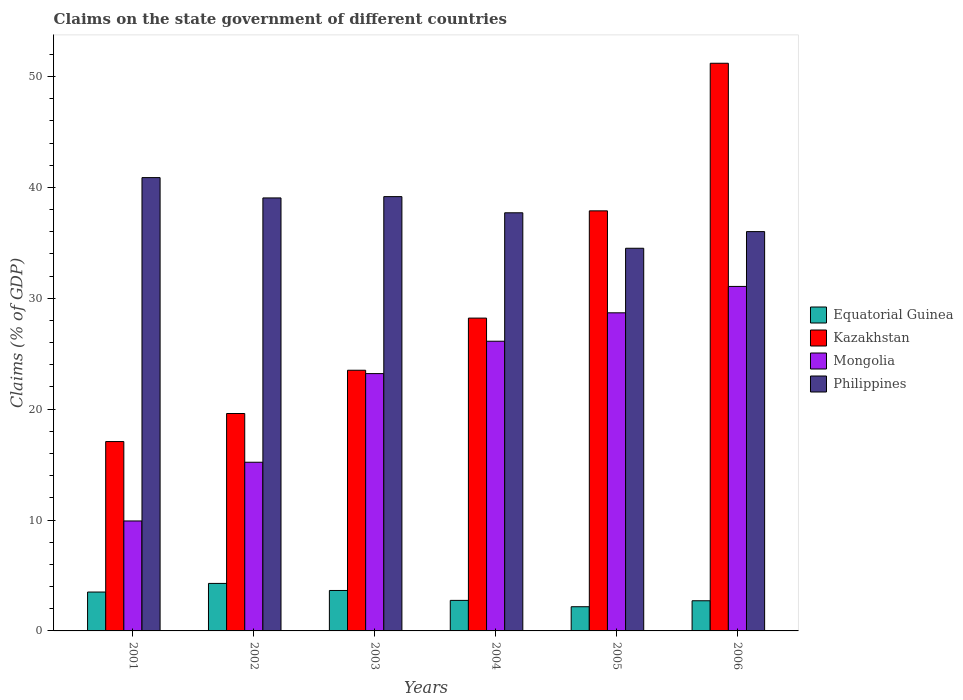How many different coloured bars are there?
Provide a succinct answer. 4. How many groups of bars are there?
Make the answer very short. 6. Are the number of bars per tick equal to the number of legend labels?
Offer a very short reply. Yes. How many bars are there on the 1st tick from the right?
Your answer should be very brief. 4. What is the label of the 4th group of bars from the left?
Provide a short and direct response. 2004. In how many cases, is the number of bars for a given year not equal to the number of legend labels?
Offer a very short reply. 0. What is the percentage of GDP claimed on the state government in Mongolia in 2001?
Your answer should be very brief. 9.92. Across all years, what is the maximum percentage of GDP claimed on the state government in Mongolia?
Provide a short and direct response. 31.07. Across all years, what is the minimum percentage of GDP claimed on the state government in Mongolia?
Provide a short and direct response. 9.92. In which year was the percentage of GDP claimed on the state government in Kazakhstan maximum?
Provide a short and direct response. 2006. What is the total percentage of GDP claimed on the state government in Equatorial Guinea in the graph?
Ensure brevity in your answer.  19.1. What is the difference between the percentage of GDP claimed on the state government in Equatorial Guinea in 2001 and that in 2006?
Your response must be concise. 0.79. What is the difference between the percentage of GDP claimed on the state government in Equatorial Guinea in 2001 and the percentage of GDP claimed on the state government in Mongolia in 2006?
Your answer should be compact. -27.56. What is the average percentage of GDP claimed on the state government in Philippines per year?
Offer a very short reply. 37.89. In the year 2003, what is the difference between the percentage of GDP claimed on the state government in Philippines and percentage of GDP claimed on the state government in Mongolia?
Provide a succinct answer. 15.96. In how many years, is the percentage of GDP claimed on the state government in Philippines greater than 28 %?
Give a very brief answer. 6. What is the ratio of the percentage of GDP claimed on the state government in Equatorial Guinea in 2002 to that in 2005?
Your response must be concise. 1.96. Is the percentage of GDP claimed on the state government in Philippines in 2002 less than that in 2003?
Give a very brief answer. Yes. What is the difference between the highest and the second highest percentage of GDP claimed on the state government in Equatorial Guinea?
Make the answer very short. 0.64. What is the difference between the highest and the lowest percentage of GDP claimed on the state government in Kazakhstan?
Your answer should be very brief. 34.12. Is the sum of the percentage of GDP claimed on the state government in Equatorial Guinea in 2001 and 2005 greater than the maximum percentage of GDP claimed on the state government in Kazakhstan across all years?
Ensure brevity in your answer.  No. Is it the case that in every year, the sum of the percentage of GDP claimed on the state government in Equatorial Guinea and percentage of GDP claimed on the state government in Philippines is greater than the sum of percentage of GDP claimed on the state government in Mongolia and percentage of GDP claimed on the state government in Kazakhstan?
Ensure brevity in your answer.  Yes. What does the 3rd bar from the left in 2004 represents?
Provide a succinct answer. Mongolia. What does the 3rd bar from the right in 2006 represents?
Keep it short and to the point. Kazakhstan. Is it the case that in every year, the sum of the percentage of GDP claimed on the state government in Philippines and percentage of GDP claimed on the state government in Mongolia is greater than the percentage of GDP claimed on the state government in Kazakhstan?
Your answer should be very brief. Yes. How many bars are there?
Provide a succinct answer. 24. What is the difference between two consecutive major ticks on the Y-axis?
Ensure brevity in your answer.  10. Are the values on the major ticks of Y-axis written in scientific E-notation?
Offer a very short reply. No. Does the graph contain any zero values?
Your answer should be compact. No. Where does the legend appear in the graph?
Provide a succinct answer. Center right. How are the legend labels stacked?
Provide a succinct answer. Vertical. What is the title of the graph?
Your answer should be very brief. Claims on the state government of different countries. What is the label or title of the X-axis?
Provide a succinct answer. Years. What is the label or title of the Y-axis?
Your answer should be compact. Claims (% of GDP). What is the Claims (% of GDP) in Equatorial Guinea in 2001?
Ensure brevity in your answer.  3.51. What is the Claims (% of GDP) of Kazakhstan in 2001?
Provide a succinct answer. 17.08. What is the Claims (% of GDP) of Mongolia in 2001?
Provide a succinct answer. 9.92. What is the Claims (% of GDP) of Philippines in 2001?
Offer a very short reply. 40.89. What is the Claims (% of GDP) of Equatorial Guinea in 2002?
Give a very brief answer. 4.28. What is the Claims (% of GDP) of Kazakhstan in 2002?
Offer a terse response. 19.61. What is the Claims (% of GDP) of Mongolia in 2002?
Keep it short and to the point. 15.21. What is the Claims (% of GDP) of Philippines in 2002?
Keep it short and to the point. 39.05. What is the Claims (% of GDP) of Equatorial Guinea in 2003?
Keep it short and to the point. 3.65. What is the Claims (% of GDP) in Kazakhstan in 2003?
Give a very brief answer. 23.51. What is the Claims (% of GDP) of Mongolia in 2003?
Provide a succinct answer. 23.21. What is the Claims (% of GDP) in Philippines in 2003?
Keep it short and to the point. 39.17. What is the Claims (% of GDP) in Equatorial Guinea in 2004?
Provide a succinct answer. 2.75. What is the Claims (% of GDP) of Kazakhstan in 2004?
Keep it short and to the point. 28.21. What is the Claims (% of GDP) in Mongolia in 2004?
Provide a short and direct response. 26.13. What is the Claims (% of GDP) of Philippines in 2004?
Offer a terse response. 37.71. What is the Claims (% of GDP) of Equatorial Guinea in 2005?
Give a very brief answer. 2.18. What is the Claims (% of GDP) of Kazakhstan in 2005?
Your answer should be compact. 37.89. What is the Claims (% of GDP) in Mongolia in 2005?
Provide a short and direct response. 28.69. What is the Claims (% of GDP) in Philippines in 2005?
Ensure brevity in your answer.  34.51. What is the Claims (% of GDP) in Equatorial Guinea in 2006?
Ensure brevity in your answer.  2.72. What is the Claims (% of GDP) in Kazakhstan in 2006?
Your response must be concise. 51.2. What is the Claims (% of GDP) of Mongolia in 2006?
Your answer should be very brief. 31.07. What is the Claims (% of GDP) in Philippines in 2006?
Your response must be concise. 36.02. Across all years, what is the maximum Claims (% of GDP) of Equatorial Guinea?
Keep it short and to the point. 4.28. Across all years, what is the maximum Claims (% of GDP) of Kazakhstan?
Ensure brevity in your answer.  51.2. Across all years, what is the maximum Claims (% of GDP) of Mongolia?
Provide a short and direct response. 31.07. Across all years, what is the maximum Claims (% of GDP) of Philippines?
Give a very brief answer. 40.89. Across all years, what is the minimum Claims (% of GDP) of Equatorial Guinea?
Offer a very short reply. 2.18. Across all years, what is the minimum Claims (% of GDP) in Kazakhstan?
Your answer should be very brief. 17.08. Across all years, what is the minimum Claims (% of GDP) in Mongolia?
Ensure brevity in your answer.  9.92. Across all years, what is the minimum Claims (% of GDP) in Philippines?
Your answer should be compact. 34.51. What is the total Claims (% of GDP) in Equatorial Guinea in the graph?
Give a very brief answer. 19.1. What is the total Claims (% of GDP) of Kazakhstan in the graph?
Offer a terse response. 177.5. What is the total Claims (% of GDP) of Mongolia in the graph?
Make the answer very short. 134.23. What is the total Claims (% of GDP) of Philippines in the graph?
Make the answer very short. 227.35. What is the difference between the Claims (% of GDP) of Equatorial Guinea in 2001 and that in 2002?
Provide a succinct answer. -0.78. What is the difference between the Claims (% of GDP) in Kazakhstan in 2001 and that in 2002?
Offer a very short reply. -2.53. What is the difference between the Claims (% of GDP) in Mongolia in 2001 and that in 2002?
Your response must be concise. -5.3. What is the difference between the Claims (% of GDP) of Philippines in 2001 and that in 2002?
Your response must be concise. 1.83. What is the difference between the Claims (% of GDP) of Equatorial Guinea in 2001 and that in 2003?
Offer a very short reply. -0.14. What is the difference between the Claims (% of GDP) in Kazakhstan in 2001 and that in 2003?
Give a very brief answer. -6.43. What is the difference between the Claims (% of GDP) in Mongolia in 2001 and that in 2003?
Provide a succinct answer. -13.29. What is the difference between the Claims (% of GDP) of Philippines in 2001 and that in 2003?
Provide a short and direct response. 1.72. What is the difference between the Claims (% of GDP) of Equatorial Guinea in 2001 and that in 2004?
Offer a terse response. 0.75. What is the difference between the Claims (% of GDP) of Kazakhstan in 2001 and that in 2004?
Provide a succinct answer. -11.14. What is the difference between the Claims (% of GDP) of Mongolia in 2001 and that in 2004?
Your answer should be very brief. -16.21. What is the difference between the Claims (% of GDP) in Philippines in 2001 and that in 2004?
Your answer should be compact. 3.17. What is the difference between the Claims (% of GDP) in Equatorial Guinea in 2001 and that in 2005?
Make the answer very short. 1.33. What is the difference between the Claims (% of GDP) of Kazakhstan in 2001 and that in 2005?
Make the answer very short. -20.81. What is the difference between the Claims (% of GDP) in Mongolia in 2001 and that in 2005?
Keep it short and to the point. -18.77. What is the difference between the Claims (% of GDP) in Philippines in 2001 and that in 2005?
Offer a very short reply. 6.37. What is the difference between the Claims (% of GDP) in Equatorial Guinea in 2001 and that in 2006?
Offer a very short reply. 0.79. What is the difference between the Claims (% of GDP) of Kazakhstan in 2001 and that in 2006?
Provide a short and direct response. -34.12. What is the difference between the Claims (% of GDP) in Mongolia in 2001 and that in 2006?
Offer a very short reply. -21.15. What is the difference between the Claims (% of GDP) of Philippines in 2001 and that in 2006?
Give a very brief answer. 4.87. What is the difference between the Claims (% of GDP) in Equatorial Guinea in 2002 and that in 2003?
Offer a terse response. 0.64. What is the difference between the Claims (% of GDP) in Kazakhstan in 2002 and that in 2003?
Offer a terse response. -3.9. What is the difference between the Claims (% of GDP) of Mongolia in 2002 and that in 2003?
Ensure brevity in your answer.  -7.99. What is the difference between the Claims (% of GDP) in Philippines in 2002 and that in 2003?
Give a very brief answer. -0.12. What is the difference between the Claims (% of GDP) of Equatorial Guinea in 2002 and that in 2004?
Make the answer very short. 1.53. What is the difference between the Claims (% of GDP) of Kazakhstan in 2002 and that in 2004?
Offer a very short reply. -8.61. What is the difference between the Claims (% of GDP) of Mongolia in 2002 and that in 2004?
Give a very brief answer. -10.92. What is the difference between the Claims (% of GDP) of Philippines in 2002 and that in 2004?
Your answer should be very brief. 1.34. What is the difference between the Claims (% of GDP) of Equatorial Guinea in 2002 and that in 2005?
Make the answer very short. 2.1. What is the difference between the Claims (% of GDP) in Kazakhstan in 2002 and that in 2005?
Your answer should be compact. -18.28. What is the difference between the Claims (% of GDP) in Mongolia in 2002 and that in 2005?
Make the answer very short. -13.48. What is the difference between the Claims (% of GDP) of Philippines in 2002 and that in 2005?
Provide a succinct answer. 4.54. What is the difference between the Claims (% of GDP) in Equatorial Guinea in 2002 and that in 2006?
Provide a succinct answer. 1.56. What is the difference between the Claims (% of GDP) of Kazakhstan in 2002 and that in 2006?
Give a very brief answer. -31.59. What is the difference between the Claims (% of GDP) in Mongolia in 2002 and that in 2006?
Offer a terse response. -15.86. What is the difference between the Claims (% of GDP) of Philippines in 2002 and that in 2006?
Offer a very short reply. 3.04. What is the difference between the Claims (% of GDP) of Equatorial Guinea in 2003 and that in 2004?
Provide a succinct answer. 0.89. What is the difference between the Claims (% of GDP) in Kazakhstan in 2003 and that in 2004?
Make the answer very short. -4.7. What is the difference between the Claims (% of GDP) of Mongolia in 2003 and that in 2004?
Your answer should be very brief. -2.92. What is the difference between the Claims (% of GDP) of Philippines in 2003 and that in 2004?
Your answer should be very brief. 1.46. What is the difference between the Claims (% of GDP) in Equatorial Guinea in 2003 and that in 2005?
Ensure brevity in your answer.  1.47. What is the difference between the Claims (% of GDP) of Kazakhstan in 2003 and that in 2005?
Provide a short and direct response. -14.38. What is the difference between the Claims (% of GDP) in Mongolia in 2003 and that in 2005?
Provide a short and direct response. -5.48. What is the difference between the Claims (% of GDP) of Philippines in 2003 and that in 2005?
Provide a short and direct response. 4.66. What is the difference between the Claims (% of GDP) of Equatorial Guinea in 2003 and that in 2006?
Offer a terse response. 0.93. What is the difference between the Claims (% of GDP) in Kazakhstan in 2003 and that in 2006?
Ensure brevity in your answer.  -27.69. What is the difference between the Claims (% of GDP) of Mongolia in 2003 and that in 2006?
Give a very brief answer. -7.86. What is the difference between the Claims (% of GDP) in Philippines in 2003 and that in 2006?
Your answer should be compact. 3.15. What is the difference between the Claims (% of GDP) in Equatorial Guinea in 2004 and that in 2005?
Give a very brief answer. 0.57. What is the difference between the Claims (% of GDP) of Kazakhstan in 2004 and that in 2005?
Your answer should be very brief. -9.67. What is the difference between the Claims (% of GDP) of Mongolia in 2004 and that in 2005?
Provide a succinct answer. -2.56. What is the difference between the Claims (% of GDP) in Philippines in 2004 and that in 2005?
Offer a very short reply. 3.2. What is the difference between the Claims (% of GDP) of Equatorial Guinea in 2004 and that in 2006?
Give a very brief answer. 0.03. What is the difference between the Claims (% of GDP) of Kazakhstan in 2004 and that in 2006?
Your response must be concise. -22.98. What is the difference between the Claims (% of GDP) of Mongolia in 2004 and that in 2006?
Your answer should be very brief. -4.94. What is the difference between the Claims (% of GDP) in Philippines in 2004 and that in 2006?
Provide a succinct answer. 1.7. What is the difference between the Claims (% of GDP) of Equatorial Guinea in 2005 and that in 2006?
Keep it short and to the point. -0.54. What is the difference between the Claims (% of GDP) of Kazakhstan in 2005 and that in 2006?
Ensure brevity in your answer.  -13.31. What is the difference between the Claims (% of GDP) of Mongolia in 2005 and that in 2006?
Your answer should be very brief. -2.38. What is the difference between the Claims (% of GDP) in Philippines in 2005 and that in 2006?
Keep it short and to the point. -1.5. What is the difference between the Claims (% of GDP) of Equatorial Guinea in 2001 and the Claims (% of GDP) of Kazakhstan in 2002?
Ensure brevity in your answer.  -16.1. What is the difference between the Claims (% of GDP) of Equatorial Guinea in 2001 and the Claims (% of GDP) of Mongolia in 2002?
Offer a terse response. -11.71. What is the difference between the Claims (% of GDP) of Equatorial Guinea in 2001 and the Claims (% of GDP) of Philippines in 2002?
Offer a terse response. -35.55. What is the difference between the Claims (% of GDP) of Kazakhstan in 2001 and the Claims (% of GDP) of Mongolia in 2002?
Offer a terse response. 1.87. What is the difference between the Claims (% of GDP) of Kazakhstan in 2001 and the Claims (% of GDP) of Philippines in 2002?
Give a very brief answer. -21.97. What is the difference between the Claims (% of GDP) in Mongolia in 2001 and the Claims (% of GDP) in Philippines in 2002?
Provide a succinct answer. -29.14. What is the difference between the Claims (% of GDP) of Equatorial Guinea in 2001 and the Claims (% of GDP) of Kazakhstan in 2003?
Provide a succinct answer. -20. What is the difference between the Claims (% of GDP) in Equatorial Guinea in 2001 and the Claims (% of GDP) in Mongolia in 2003?
Your answer should be very brief. -19.7. What is the difference between the Claims (% of GDP) of Equatorial Guinea in 2001 and the Claims (% of GDP) of Philippines in 2003?
Your response must be concise. -35.66. What is the difference between the Claims (% of GDP) of Kazakhstan in 2001 and the Claims (% of GDP) of Mongolia in 2003?
Keep it short and to the point. -6.13. What is the difference between the Claims (% of GDP) of Kazakhstan in 2001 and the Claims (% of GDP) of Philippines in 2003?
Make the answer very short. -22.09. What is the difference between the Claims (% of GDP) in Mongolia in 2001 and the Claims (% of GDP) in Philippines in 2003?
Your answer should be compact. -29.25. What is the difference between the Claims (% of GDP) in Equatorial Guinea in 2001 and the Claims (% of GDP) in Kazakhstan in 2004?
Keep it short and to the point. -24.71. What is the difference between the Claims (% of GDP) in Equatorial Guinea in 2001 and the Claims (% of GDP) in Mongolia in 2004?
Provide a short and direct response. -22.62. What is the difference between the Claims (% of GDP) of Equatorial Guinea in 2001 and the Claims (% of GDP) of Philippines in 2004?
Ensure brevity in your answer.  -34.21. What is the difference between the Claims (% of GDP) of Kazakhstan in 2001 and the Claims (% of GDP) of Mongolia in 2004?
Offer a very short reply. -9.05. What is the difference between the Claims (% of GDP) in Kazakhstan in 2001 and the Claims (% of GDP) in Philippines in 2004?
Provide a short and direct response. -20.63. What is the difference between the Claims (% of GDP) of Mongolia in 2001 and the Claims (% of GDP) of Philippines in 2004?
Offer a very short reply. -27.8. What is the difference between the Claims (% of GDP) in Equatorial Guinea in 2001 and the Claims (% of GDP) in Kazakhstan in 2005?
Your answer should be compact. -34.38. What is the difference between the Claims (% of GDP) of Equatorial Guinea in 2001 and the Claims (% of GDP) of Mongolia in 2005?
Offer a terse response. -25.18. What is the difference between the Claims (% of GDP) of Equatorial Guinea in 2001 and the Claims (% of GDP) of Philippines in 2005?
Offer a very short reply. -31.01. What is the difference between the Claims (% of GDP) in Kazakhstan in 2001 and the Claims (% of GDP) in Mongolia in 2005?
Provide a succinct answer. -11.61. What is the difference between the Claims (% of GDP) of Kazakhstan in 2001 and the Claims (% of GDP) of Philippines in 2005?
Ensure brevity in your answer.  -17.43. What is the difference between the Claims (% of GDP) in Mongolia in 2001 and the Claims (% of GDP) in Philippines in 2005?
Offer a terse response. -24.6. What is the difference between the Claims (% of GDP) in Equatorial Guinea in 2001 and the Claims (% of GDP) in Kazakhstan in 2006?
Make the answer very short. -47.69. What is the difference between the Claims (% of GDP) in Equatorial Guinea in 2001 and the Claims (% of GDP) in Mongolia in 2006?
Your answer should be compact. -27.56. What is the difference between the Claims (% of GDP) of Equatorial Guinea in 2001 and the Claims (% of GDP) of Philippines in 2006?
Make the answer very short. -32.51. What is the difference between the Claims (% of GDP) of Kazakhstan in 2001 and the Claims (% of GDP) of Mongolia in 2006?
Make the answer very short. -13.99. What is the difference between the Claims (% of GDP) of Kazakhstan in 2001 and the Claims (% of GDP) of Philippines in 2006?
Your response must be concise. -18.94. What is the difference between the Claims (% of GDP) of Mongolia in 2001 and the Claims (% of GDP) of Philippines in 2006?
Your response must be concise. -26.1. What is the difference between the Claims (% of GDP) of Equatorial Guinea in 2002 and the Claims (% of GDP) of Kazakhstan in 2003?
Offer a terse response. -19.23. What is the difference between the Claims (% of GDP) in Equatorial Guinea in 2002 and the Claims (% of GDP) in Mongolia in 2003?
Offer a very short reply. -18.92. What is the difference between the Claims (% of GDP) of Equatorial Guinea in 2002 and the Claims (% of GDP) of Philippines in 2003?
Offer a very short reply. -34.89. What is the difference between the Claims (% of GDP) in Kazakhstan in 2002 and the Claims (% of GDP) in Mongolia in 2003?
Keep it short and to the point. -3.6. What is the difference between the Claims (% of GDP) of Kazakhstan in 2002 and the Claims (% of GDP) of Philippines in 2003?
Ensure brevity in your answer.  -19.56. What is the difference between the Claims (% of GDP) in Mongolia in 2002 and the Claims (% of GDP) in Philippines in 2003?
Give a very brief answer. -23.96. What is the difference between the Claims (% of GDP) in Equatorial Guinea in 2002 and the Claims (% of GDP) in Kazakhstan in 2004?
Keep it short and to the point. -23.93. What is the difference between the Claims (% of GDP) in Equatorial Guinea in 2002 and the Claims (% of GDP) in Mongolia in 2004?
Your answer should be compact. -21.84. What is the difference between the Claims (% of GDP) of Equatorial Guinea in 2002 and the Claims (% of GDP) of Philippines in 2004?
Offer a terse response. -33.43. What is the difference between the Claims (% of GDP) in Kazakhstan in 2002 and the Claims (% of GDP) in Mongolia in 2004?
Your answer should be very brief. -6.52. What is the difference between the Claims (% of GDP) of Kazakhstan in 2002 and the Claims (% of GDP) of Philippines in 2004?
Offer a very short reply. -18.1. What is the difference between the Claims (% of GDP) of Mongolia in 2002 and the Claims (% of GDP) of Philippines in 2004?
Provide a short and direct response. -22.5. What is the difference between the Claims (% of GDP) of Equatorial Guinea in 2002 and the Claims (% of GDP) of Kazakhstan in 2005?
Your answer should be very brief. -33.6. What is the difference between the Claims (% of GDP) in Equatorial Guinea in 2002 and the Claims (% of GDP) in Mongolia in 2005?
Ensure brevity in your answer.  -24.41. What is the difference between the Claims (% of GDP) in Equatorial Guinea in 2002 and the Claims (% of GDP) in Philippines in 2005?
Provide a succinct answer. -30.23. What is the difference between the Claims (% of GDP) of Kazakhstan in 2002 and the Claims (% of GDP) of Mongolia in 2005?
Your answer should be very brief. -9.08. What is the difference between the Claims (% of GDP) in Kazakhstan in 2002 and the Claims (% of GDP) in Philippines in 2005?
Make the answer very short. -14.9. What is the difference between the Claims (% of GDP) of Mongolia in 2002 and the Claims (% of GDP) of Philippines in 2005?
Give a very brief answer. -19.3. What is the difference between the Claims (% of GDP) in Equatorial Guinea in 2002 and the Claims (% of GDP) in Kazakhstan in 2006?
Your response must be concise. -46.91. What is the difference between the Claims (% of GDP) of Equatorial Guinea in 2002 and the Claims (% of GDP) of Mongolia in 2006?
Your response must be concise. -26.79. What is the difference between the Claims (% of GDP) of Equatorial Guinea in 2002 and the Claims (% of GDP) of Philippines in 2006?
Your answer should be very brief. -31.73. What is the difference between the Claims (% of GDP) in Kazakhstan in 2002 and the Claims (% of GDP) in Mongolia in 2006?
Offer a terse response. -11.46. What is the difference between the Claims (% of GDP) in Kazakhstan in 2002 and the Claims (% of GDP) in Philippines in 2006?
Provide a succinct answer. -16.41. What is the difference between the Claims (% of GDP) of Mongolia in 2002 and the Claims (% of GDP) of Philippines in 2006?
Offer a very short reply. -20.8. What is the difference between the Claims (% of GDP) of Equatorial Guinea in 2003 and the Claims (% of GDP) of Kazakhstan in 2004?
Offer a terse response. -24.57. What is the difference between the Claims (% of GDP) in Equatorial Guinea in 2003 and the Claims (% of GDP) in Mongolia in 2004?
Give a very brief answer. -22.48. What is the difference between the Claims (% of GDP) in Equatorial Guinea in 2003 and the Claims (% of GDP) in Philippines in 2004?
Make the answer very short. -34.06. What is the difference between the Claims (% of GDP) in Kazakhstan in 2003 and the Claims (% of GDP) in Mongolia in 2004?
Offer a very short reply. -2.62. What is the difference between the Claims (% of GDP) of Kazakhstan in 2003 and the Claims (% of GDP) of Philippines in 2004?
Give a very brief answer. -14.2. What is the difference between the Claims (% of GDP) of Mongolia in 2003 and the Claims (% of GDP) of Philippines in 2004?
Make the answer very short. -14.5. What is the difference between the Claims (% of GDP) in Equatorial Guinea in 2003 and the Claims (% of GDP) in Kazakhstan in 2005?
Make the answer very short. -34.24. What is the difference between the Claims (% of GDP) in Equatorial Guinea in 2003 and the Claims (% of GDP) in Mongolia in 2005?
Your answer should be compact. -25.04. What is the difference between the Claims (% of GDP) of Equatorial Guinea in 2003 and the Claims (% of GDP) of Philippines in 2005?
Give a very brief answer. -30.87. What is the difference between the Claims (% of GDP) of Kazakhstan in 2003 and the Claims (% of GDP) of Mongolia in 2005?
Give a very brief answer. -5.18. What is the difference between the Claims (% of GDP) of Kazakhstan in 2003 and the Claims (% of GDP) of Philippines in 2005?
Provide a succinct answer. -11. What is the difference between the Claims (% of GDP) in Mongolia in 2003 and the Claims (% of GDP) in Philippines in 2005?
Provide a succinct answer. -11.31. What is the difference between the Claims (% of GDP) of Equatorial Guinea in 2003 and the Claims (% of GDP) of Kazakhstan in 2006?
Give a very brief answer. -47.55. What is the difference between the Claims (% of GDP) of Equatorial Guinea in 2003 and the Claims (% of GDP) of Mongolia in 2006?
Ensure brevity in your answer.  -27.42. What is the difference between the Claims (% of GDP) in Equatorial Guinea in 2003 and the Claims (% of GDP) in Philippines in 2006?
Your response must be concise. -32.37. What is the difference between the Claims (% of GDP) in Kazakhstan in 2003 and the Claims (% of GDP) in Mongolia in 2006?
Offer a terse response. -7.56. What is the difference between the Claims (% of GDP) of Kazakhstan in 2003 and the Claims (% of GDP) of Philippines in 2006?
Give a very brief answer. -12.5. What is the difference between the Claims (% of GDP) in Mongolia in 2003 and the Claims (% of GDP) in Philippines in 2006?
Your response must be concise. -12.81. What is the difference between the Claims (% of GDP) of Equatorial Guinea in 2004 and the Claims (% of GDP) of Kazakhstan in 2005?
Ensure brevity in your answer.  -35.13. What is the difference between the Claims (% of GDP) in Equatorial Guinea in 2004 and the Claims (% of GDP) in Mongolia in 2005?
Ensure brevity in your answer.  -25.94. What is the difference between the Claims (% of GDP) of Equatorial Guinea in 2004 and the Claims (% of GDP) of Philippines in 2005?
Ensure brevity in your answer.  -31.76. What is the difference between the Claims (% of GDP) in Kazakhstan in 2004 and the Claims (% of GDP) in Mongolia in 2005?
Provide a short and direct response. -0.48. What is the difference between the Claims (% of GDP) of Kazakhstan in 2004 and the Claims (% of GDP) of Philippines in 2005?
Provide a short and direct response. -6.3. What is the difference between the Claims (% of GDP) in Mongolia in 2004 and the Claims (% of GDP) in Philippines in 2005?
Your response must be concise. -8.38. What is the difference between the Claims (% of GDP) of Equatorial Guinea in 2004 and the Claims (% of GDP) of Kazakhstan in 2006?
Give a very brief answer. -48.44. What is the difference between the Claims (% of GDP) in Equatorial Guinea in 2004 and the Claims (% of GDP) in Mongolia in 2006?
Offer a terse response. -28.32. What is the difference between the Claims (% of GDP) of Equatorial Guinea in 2004 and the Claims (% of GDP) of Philippines in 2006?
Your answer should be very brief. -33.26. What is the difference between the Claims (% of GDP) of Kazakhstan in 2004 and the Claims (% of GDP) of Mongolia in 2006?
Keep it short and to the point. -2.86. What is the difference between the Claims (% of GDP) in Kazakhstan in 2004 and the Claims (% of GDP) in Philippines in 2006?
Make the answer very short. -7.8. What is the difference between the Claims (% of GDP) of Mongolia in 2004 and the Claims (% of GDP) of Philippines in 2006?
Make the answer very short. -9.89. What is the difference between the Claims (% of GDP) of Equatorial Guinea in 2005 and the Claims (% of GDP) of Kazakhstan in 2006?
Keep it short and to the point. -49.02. What is the difference between the Claims (% of GDP) in Equatorial Guinea in 2005 and the Claims (% of GDP) in Mongolia in 2006?
Your answer should be very brief. -28.89. What is the difference between the Claims (% of GDP) in Equatorial Guinea in 2005 and the Claims (% of GDP) in Philippines in 2006?
Your answer should be very brief. -33.83. What is the difference between the Claims (% of GDP) of Kazakhstan in 2005 and the Claims (% of GDP) of Mongolia in 2006?
Provide a short and direct response. 6.82. What is the difference between the Claims (% of GDP) in Kazakhstan in 2005 and the Claims (% of GDP) in Philippines in 2006?
Give a very brief answer. 1.87. What is the difference between the Claims (% of GDP) of Mongolia in 2005 and the Claims (% of GDP) of Philippines in 2006?
Your response must be concise. -7.33. What is the average Claims (% of GDP) of Equatorial Guinea per year?
Make the answer very short. 3.18. What is the average Claims (% of GDP) in Kazakhstan per year?
Your answer should be very brief. 29.58. What is the average Claims (% of GDP) of Mongolia per year?
Your response must be concise. 22.37. What is the average Claims (% of GDP) of Philippines per year?
Keep it short and to the point. 37.89. In the year 2001, what is the difference between the Claims (% of GDP) in Equatorial Guinea and Claims (% of GDP) in Kazakhstan?
Keep it short and to the point. -13.57. In the year 2001, what is the difference between the Claims (% of GDP) of Equatorial Guinea and Claims (% of GDP) of Mongolia?
Offer a terse response. -6.41. In the year 2001, what is the difference between the Claims (% of GDP) of Equatorial Guinea and Claims (% of GDP) of Philippines?
Offer a terse response. -37.38. In the year 2001, what is the difference between the Claims (% of GDP) in Kazakhstan and Claims (% of GDP) in Mongolia?
Make the answer very short. 7.16. In the year 2001, what is the difference between the Claims (% of GDP) in Kazakhstan and Claims (% of GDP) in Philippines?
Your answer should be very brief. -23.81. In the year 2001, what is the difference between the Claims (% of GDP) in Mongolia and Claims (% of GDP) in Philippines?
Your answer should be very brief. -30.97. In the year 2002, what is the difference between the Claims (% of GDP) in Equatorial Guinea and Claims (% of GDP) in Kazakhstan?
Your answer should be very brief. -15.32. In the year 2002, what is the difference between the Claims (% of GDP) in Equatorial Guinea and Claims (% of GDP) in Mongolia?
Your answer should be compact. -10.93. In the year 2002, what is the difference between the Claims (% of GDP) in Equatorial Guinea and Claims (% of GDP) in Philippines?
Give a very brief answer. -34.77. In the year 2002, what is the difference between the Claims (% of GDP) in Kazakhstan and Claims (% of GDP) in Mongolia?
Provide a succinct answer. 4.4. In the year 2002, what is the difference between the Claims (% of GDP) of Kazakhstan and Claims (% of GDP) of Philippines?
Provide a short and direct response. -19.44. In the year 2002, what is the difference between the Claims (% of GDP) in Mongolia and Claims (% of GDP) in Philippines?
Offer a terse response. -23.84. In the year 2003, what is the difference between the Claims (% of GDP) in Equatorial Guinea and Claims (% of GDP) in Kazakhstan?
Ensure brevity in your answer.  -19.86. In the year 2003, what is the difference between the Claims (% of GDP) of Equatorial Guinea and Claims (% of GDP) of Mongolia?
Ensure brevity in your answer.  -19.56. In the year 2003, what is the difference between the Claims (% of GDP) in Equatorial Guinea and Claims (% of GDP) in Philippines?
Offer a terse response. -35.52. In the year 2003, what is the difference between the Claims (% of GDP) in Kazakhstan and Claims (% of GDP) in Mongolia?
Provide a succinct answer. 0.3. In the year 2003, what is the difference between the Claims (% of GDP) in Kazakhstan and Claims (% of GDP) in Philippines?
Your response must be concise. -15.66. In the year 2003, what is the difference between the Claims (% of GDP) of Mongolia and Claims (% of GDP) of Philippines?
Offer a terse response. -15.96. In the year 2004, what is the difference between the Claims (% of GDP) in Equatorial Guinea and Claims (% of GDP) in Kazakhstan?
Provide a short and direct response. -25.46. In the year 2004, what is the difference between the Claims (% of GDP) in Equatorial Guinea and Claims (% of GDP) in Mongolia?
Your response must be concise. -23.37. In the year 2004, what is the difference between the Claims (% of GDP) in Equatorial Guinea and Claims (% of GDP) in Philippines?
Give a very brief answer. -34.96. In the year 2004, what is the difference between the Claims (% of GDP) of Kazakhstan and Claims (% of GDP) of Mongolia?
Give a very brief answer. 2.09. In the year 2004, what is the difference between the Claims (% of GDP) of Kazakhstan and Claims (% of GDP) of Philippines?
Make the answer very short. -9.5. In the year 2004, what is the difference between the Claims (% of GDP) in Mongolia and Claims (% of GDP) in Philippines?
Offer a terse response. -11.58. In the year 2005, what is the difference between the Claims (% of GDP) in Equatorial Guinea and Claims (% of GDP) in Kazakhstan?
Your answer should be compact. -35.71. In the year 2005, what is the difference between the Claims (% of GDP) in Equatorial Guinea and Claims (% of GDP) in Mongolia?
Provide a short and direct response. -26.51. In the year 2005, what is the difference between the Claims (% of GDP) in Equatorial Guinea and Claims (% of GDP) in Philippines?
Give a very brief answer. -32.33. In the year 2005, what is the difference between the Claims (% of GDP) in Kazakhstan and Claims (% of GDP) in Mongolia?
Offer a terse response. 9.2. In the year 2005, what is the difference between the Claims (% of GDP) in Kazakhstan and Claims (% of GDP) in Philippines?
Offer a very short reply. 3.37. In the year 2005, what is the difference between the Claims (% of GDP) of Mongolia and Claims (% of GDP) of Philippines?
Offer a terse response. -5.82. In the year 2006, what is the difference between the Claims (% of GDP) in Equatorial Guinea and Claims (% of GDP) in Kazakhstan?
Provide a short and direct response. -48.48. In the year 2006, what is the difference between the Claims (% of GDP) of Equatorial Guinea and Claims (% of GDP) of Mongolia?
Offer a very short reply. -28.35. In the year 2006, what is the difference between the Claims (% of GDP) in Equatorial Guinea and Claims (% of GDP) in Philippines?
Offer a terse response. -33.3. In the year 2006, what is the difference between the Claims (% of GDP) in Kazakhstan and Claims (% of GDP) in Mongolia?
Ensure brevity in your answer.  20.13. In the year 2006, what is the difference between the Claims (% of GDP) in Kazakhstan and Claims (% of GDP) in Philippines?
Give a very brief answer. 15.18. In the year 2006, what is the difference between the Claims (% of GDP) in Mongolia and Claims (% of GDP) in Philippines?
Keep it short and to the point. -4.95. What is the ratio of the Claims (% of GDP) in Equatorial Guinea in 2001 to that in 2002?
Your response must be concise. 0.82. What is the ratio of the Claims (% of GDP) of Kazakhstan in 2001 to that in 2002?
Offer a terse response. 0.87. What is the ratio of the Claims (% of GDP) in Mongolia in 2001 to that in 2002?
Provide a short and direct response. 0.65. What is the ratio of the Claims (% of GDP) in Philippines in 2001 to that in 2002?
Make the answer very short. 1.05. What is the ratio of the Claims (% of GDP) of Equatorial Guinea in 2001 to that in 2003?
Make the answer very short. 0.96. What is the ratio of the Claims (% of GDP) of Kazakhstan in 2001 to that in 2003?
Make the answer very short. 0.73. What is the ratio of the Claims (% of GDP) of Mongolia in 2001 to that in 2003?
Keep it short and to the point. 0.43. What is the ratio of the Claims (% of GDP) in Philippines in 2001 to that in 2003?
Offer a very short reply. 1.04. What is the ratio of the Claims (% of GDP) in Equatorial Guinea in 2001 to that in 2004?
Provide a short and direct response. 1.27. What is the ratio of the Claims (% of GDP) in Kazakhstan in 2001 to that in 2004?
Your answer should be compact. 0.61. What is the ratio of the Claims (% of GDP) in Mongolia in 2001 to that in 2004?
Offer a terse response. 0.38. What is the ratio of the Claims (% of GDP) of Philippines in 2001 to that in 2004?
Provide a succinct answer. 1.08. What is the ratio of the Claims (% of GDP) of Equatorial Guinea in 2001 to that in 2005?
Your answer should be very brief. 1.61. What is the ratio of the Claims (% of GDP) in Kazakhstan in 2001 to that in 2005?
Ensure brevity in your answer.  0.45. What is the ratio of the Claims (% of GDP) in Mongolia in 2001 to that in 2005?
Offer a very short reply. 0.35. What is the ratio of the Claims (% of GDP) in Philippines in 2001 to that in 2005?
Provide a succinct answer. 1.18. What is the ratio of the Claims (% of GDP) of Equatorial Guinea in 2001 to that in 2006?
Offer a very short reply. 1.29. What is the ratio of the Claims (% of GDP) of Kazakhstan in 2001 to that in 2006?
Your answer should be very brief. 0.33. What is the ratio of the Claims (% of GDP) of Mongolia in 2001 to that in 2006?
Give a very brief answer. 0.32. What is the ratio of the Claims (% of GDP) of Philippines in 2001 to that in 2006?
Offer a terse response. 1.14. What is the ratio of the Claims (% of GDP) of Equatorial Guinea in 2002 to that in 2003?
Your answer should be compact. 1.17. What is the ratio of the Claims (% of GDP) in Kazakhstan in 2002 to that in 2003?
Provide a short and direct response. 0.83. What is the ratio of the Claims (% of GDP) in Mongolia in 2002 to that in 2003?
Your answer should be very brief. 0.66. What is the ratio of the Claims (% of GDP) in Equatorial Guinea in 2002 to that in 2004?
Your answer should be compact. 1.56. What is the ratio of the Claims (% of GDP) in Kazakhstan in 2002 to that in 2004?
Ensure brevity in your answer.  0.69. What is the ratio of the Claims (% of GDP) of Mongolia in 2002 to that in 2004?
Your response must be concise. 0.58. What is the ratio of the Claims (% of GDP) of Philippines in 2002 to that in 2004?
Give a very brief answer. 1.04. What is the ratio of the Claims (% of GDP) in Equatorial Guinea in 2002 to that in 2005?
Provide a succinct answer. 1.96. What is the ratio of the Claims (% of GDP) of Kazakhstan in 2002 to that in 2005?
Make the answer very short. 0.52. What is the ratio of the Claims (% of GDP) in Mongolia in 2002 to that in 2005?
Provide a succinct answer. 0.53. What is the ratio of the Claims (% of GDP) of Philippines in 2002 to that in 2005?
Your answer should be very brief. 1.13. What is the ratio of the Claims (% of GDP) of Equatorial Guinea in 2002 to that in 2006?
Offer a very short reply. 1.57. What is the ratio of the Claims (% of GDP) in Kazakhstan in 2002 to that in 2006?
Make the answer very short. 0.38. What is the ratio of the Claims (% of GDP) in Mongolia in 2002 to that in 2006?
Make the answer very short. 0.49. What is the ratio of the Claims (% of GDP) in Philippines in 2002 to that in 2006?
Ensure brevity in your answer.  1.08. What is the ratio of the Claims (% of GDP) in Equatorial Guinea in 2003 to that in 2004?
Keep it short and to the point. 1.32. What is the ratio of the Claims (% of GDP) in Kazakhstan in 2003 to that in 2004?
Offer a terse response. 0.83. What is the ratio of the Claims (% of GDP) of Mongolia in 2003 to that in 2004?
Ensure brevity in your answer.  0.89. What is the ratio of the Claims (% of GDP) in Philippines in 2003 to that in 2004?
Offer a very short reply. 1.04. What is the ratio of the Claims (% of GDP) in Equatorial Guinea in 2003 to that in 2005?
Provide a short and direct response. 1.67. What is the ratio of the Claims (% of GDP) in Kazakhstan in 2003 to that in 2005?
Give a very brief answer. 0.62. What is the ratio of the Claims (% of GDP) of Mongolia in 2003 to that in 2005?
Make the answer very short. 0.81. What is the ratio of the Claims (% of GDP) in Philippines in 2003 to that in 2005?
Make the answer very short. 1.13. What is the ratio of the Claims (% of GDP) in Equatorial Guinea in 2003 to that in 2006?
Make the answer very short. 1.34. What is the ratio of the Claims (% of GDP) of Kazakhstan in 2003 to that in 2006?
Provide a succinct answer. 0.46. What is the ratio of the Claims (% of GDP) of Mongolia in 2003 to that in 2006?
Provide a succinct answer. 0.75. What is the ratio of the Claims (% of GDP) in Philippines in 2003 to that in 2006?
Keep it short and to the point. 1.09. What is the ratio of the Claims (% of GDP) in Equatorial Guinea in 2004 to that in 2005?
Provide a succinct answer. 1.26. What is the ratio of the Claims (% of GDP) in Kazakhstan in 2004 to that in 2005?
Your answer should be compact. 0.74. What is the ratio of the Claims (% of GDP) of Mongolia in 2004 to that in 2005?
Provide a succinct answer. 0.91. What is the ratio of the Claims (% of GDP) in Philippines in 2004 to that in 2005?
Give a very brief answer. 1.09. What is the ratio of the Claims (% of GDP) of Equatorial Guinea in 2004 to that in 2006?
Your answer should be very brief. 1.01. What is the ratio of the Claims (% of GDP) in Kazakhstan in 2004 to that in 2006?
Your answer should be compact. 0.55. What is the ratio of the Claims (% of GDP) in Mongolia in 2004 to that in 2006?
Keep it short and to the point. 0.84. What is the ratio of the Claims (% of GDP) in Philippines in 2004 to that in 2006?
Provide a short and direct response. 1.05. What is the ratio of the Claims (% of GDP) of Equatorial Guinea in 2005 to that in 2006?
Your response must be concise. 0.8. What is the ratio of the Claims (% of GDP) of Kazakhstan in 2005 to that in 2006?
Ensure brevity in your answer.  0.74. What is the ratio of the Claims (% of GDP) of Mongolia in 2005 to that in 2006?
Your answer should be compact. 0.92. What is the ratio of the Claims (% of GDP) in Philippines in 2005 to that in 2006?
Provide a succinct answer. 0.96. What is the difference between the highest and the second highest Claims (% of GDP) of Equatorial Guinea?
Offer a very short reply. 0.64. What is the difference between the highest and the second highest Claims (% of GDP) of Kazakhstan?
Make the answer very short. 13.31. What is the difference between the highest and the second highest Claims (% of GDP) in Mongolia?
Your answer should be very brief. 2.38. What is the difference between the highest and the second highest Claims (% of GDP) of Philippines?
Keep it short and to the point. 1.72. What is the difference between the highest and the lowest Claims (% of GDP) of Equatorial Guinea?
Keep it short and to the point. 2.1. What is the difference between the highest and the lowest Claims (% of GDP) of Kazakhstan?
Your answer should be very brief. 34.12. What is the difference between the highest and the lowest Claims (% of GDP) in Mongolia?
Offer a terse response. 21.15. What is the difference between the highest and the lowest Claims (% of GDP) in Philippines?
Ensure brevity in your answer.  6.37. 